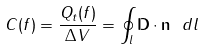Convert formula to latex. <formula><loc_0><loc_0><loc_500><loc_500>C ( f ) = \frac { Q _ { t } ( f ) } { \Delta V } = \oint _ { l } { \mathbf D } \cdot { \mathbf n } \ d l</formula> 